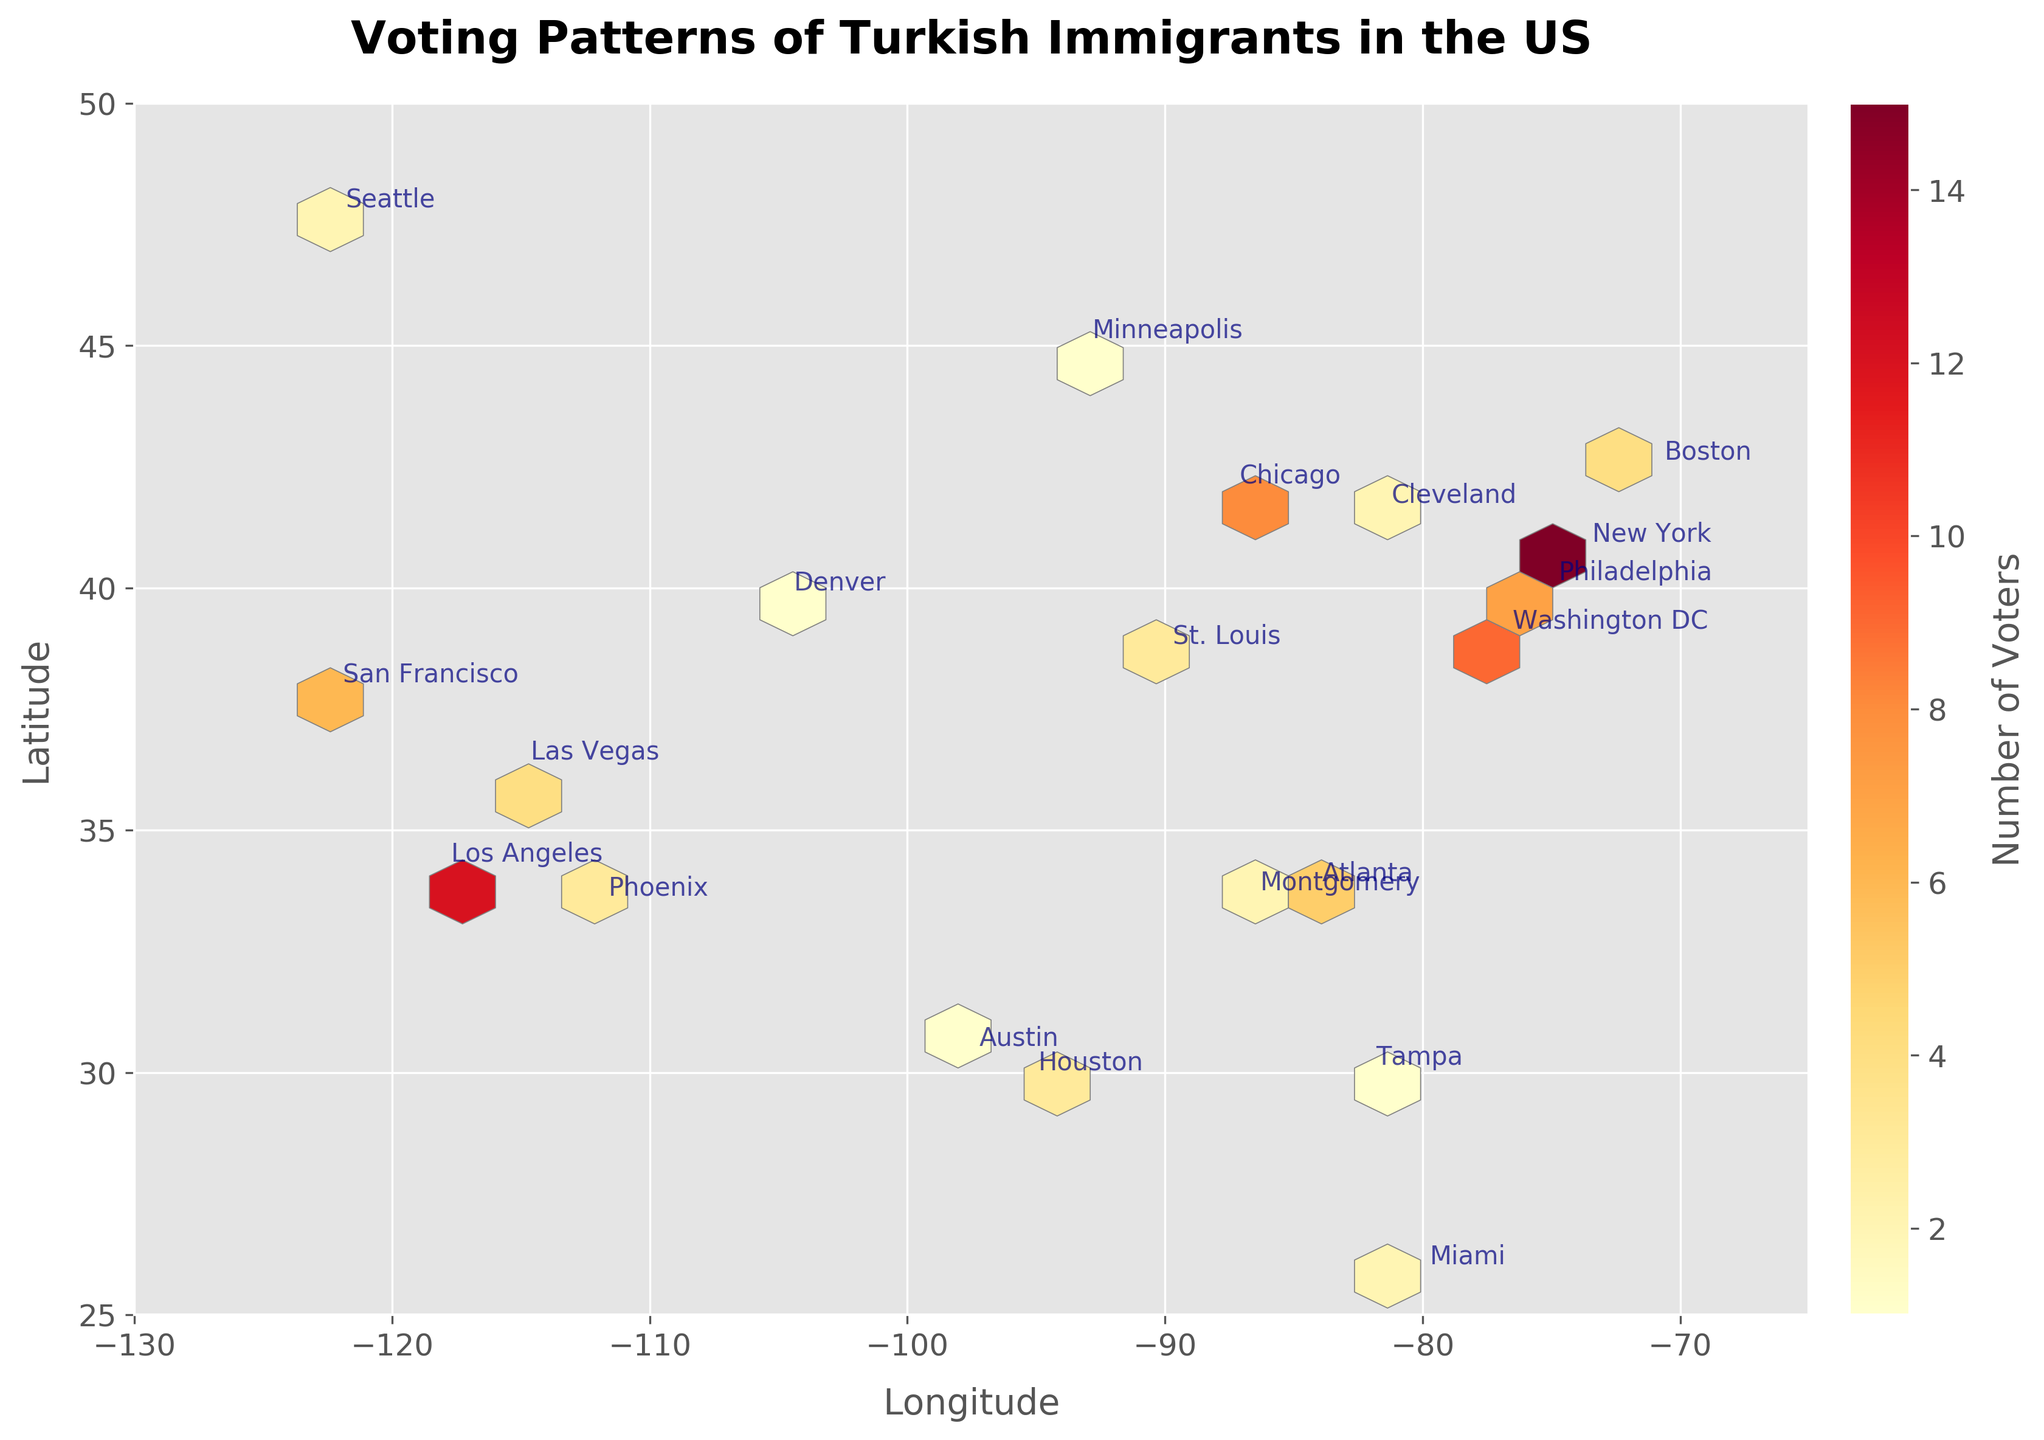What is the title of the hexbin plot? The title of the plot is located at the top, using a bold font and larger size compared to other text elements.
Answer: Voting Patterns of Turkish Immigrants in the US How many Democratic regions are shown in the plot? Look for annotations on the plot with the label "Democratic" and count them.
Answer: 12 Which city has the highest number of voters according to the plot? Find the hexagon with the darkest shade in the plot and check the annotation near it.
Answer: New York How many cities have fewer than 5 voters? Count the number of hexagon annotations with a count of less than 5.
Answer: 9 Which region has the closest number of voters compared to San Francisco? Look at the count of voters for San Francisco in the plot and find another region with a similar count.
Answer: Las Vegas Which political affiliation is more prevalent among Turkish immigrants in the US based on the plot? Compare the number of Democratic and Republican annotations in the plot to see which one appears more frequently.
Answer: Democratic What is the geographical region with the fewest Turkish immigrant voters? Identify the annotation with the smallest count in the plot.
Answer: Austin How does the voting pattern differ between coastal and inland cities? Compare the counts of voters between coastal cities (e.g., New York, Los Angeles) and inland cities (e.g., Chicago, Denver).
Answer: Coastal cities generally have higher voter counts Which is the southernmost city with Republican voters on the plot? Look for the annotation labeled "Republican" that is furthest south on the y-axis of the plot.
Answer: Miami How many regions are located west of -100 longitude and have a Republican affiliation? Look for Republican regions with longitudes less than -100 and count them.
Answer: 5 